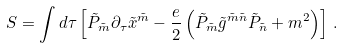Convert formula to latex. <formula><loc_0><loc_0><loc_500><loc_500>S = \int d \tau \left [ \tilde { P } _ { \tilde { m } } \partial _ { \tau } \tilde { x } ^ { \tilde { m } } - \frac { e } { 2 } \left ( \tilde { P } _ { \tilde { m } } \tilde { g } ^ { \tilde { m } \tilde { n } } \tilde { P } _ { \tilde { n } } + m ^ { 2 } \right ) \right ] \, .</formula> 